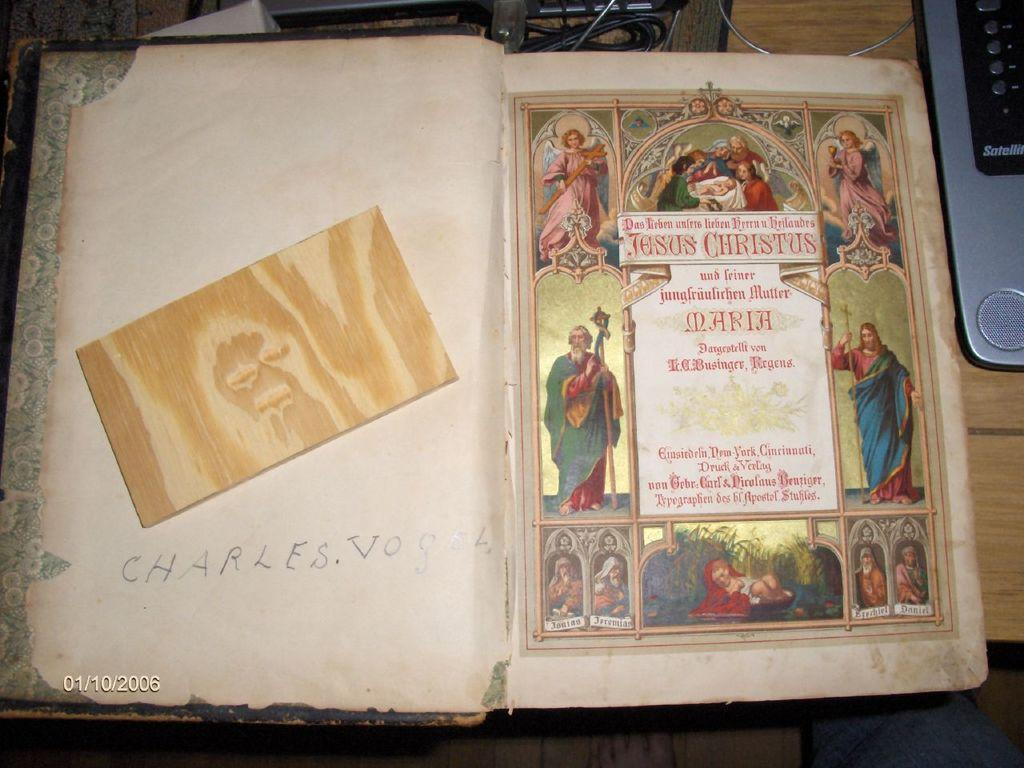Provide a one-sentence caption for the provided image. An antique book has the name Charles Vogel written inside the first page. 